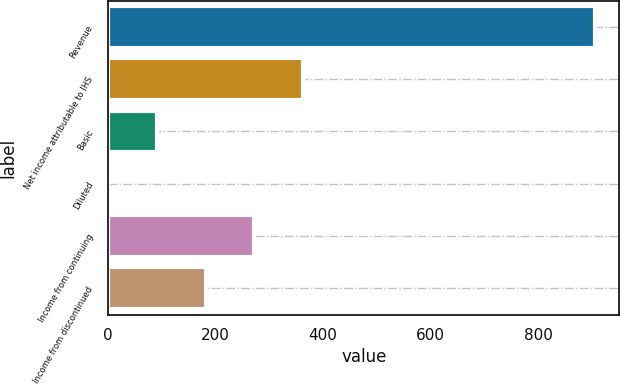<chart> <loc_0><loc_0><loc_500><loc_500><bar_chart><fcel>Revenue<fcel>Net income attributable to IHS<fcel>Basic<fcel>Diluted<fcel>Income from continuing<fcel>Income from discontinued<nl><fcel>906.1<fcel>362.6<fcel>90.83<fcel>0.24<fcel>272.01<fcel>181.42<nl></chart> 